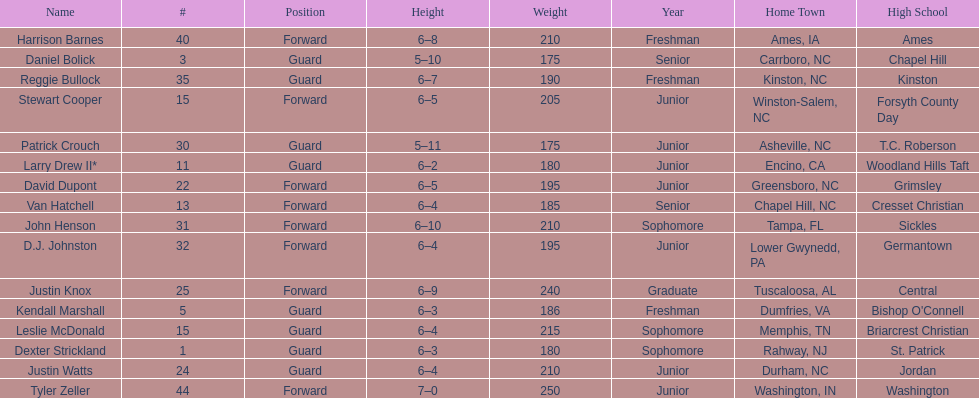Tallest player on the team Tyler Zeller. 